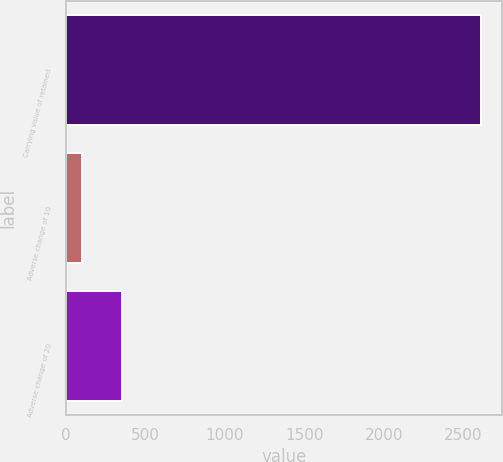<chart> <loc_0><loc_0><loc_500><loc_500><bar_chart><fcel>Carrying value of retained<fcel>Adverse change of 10<fcel>Adverse change of 20<nl><fcel>2611<fcel>101<fcel>352<nl></chart> 